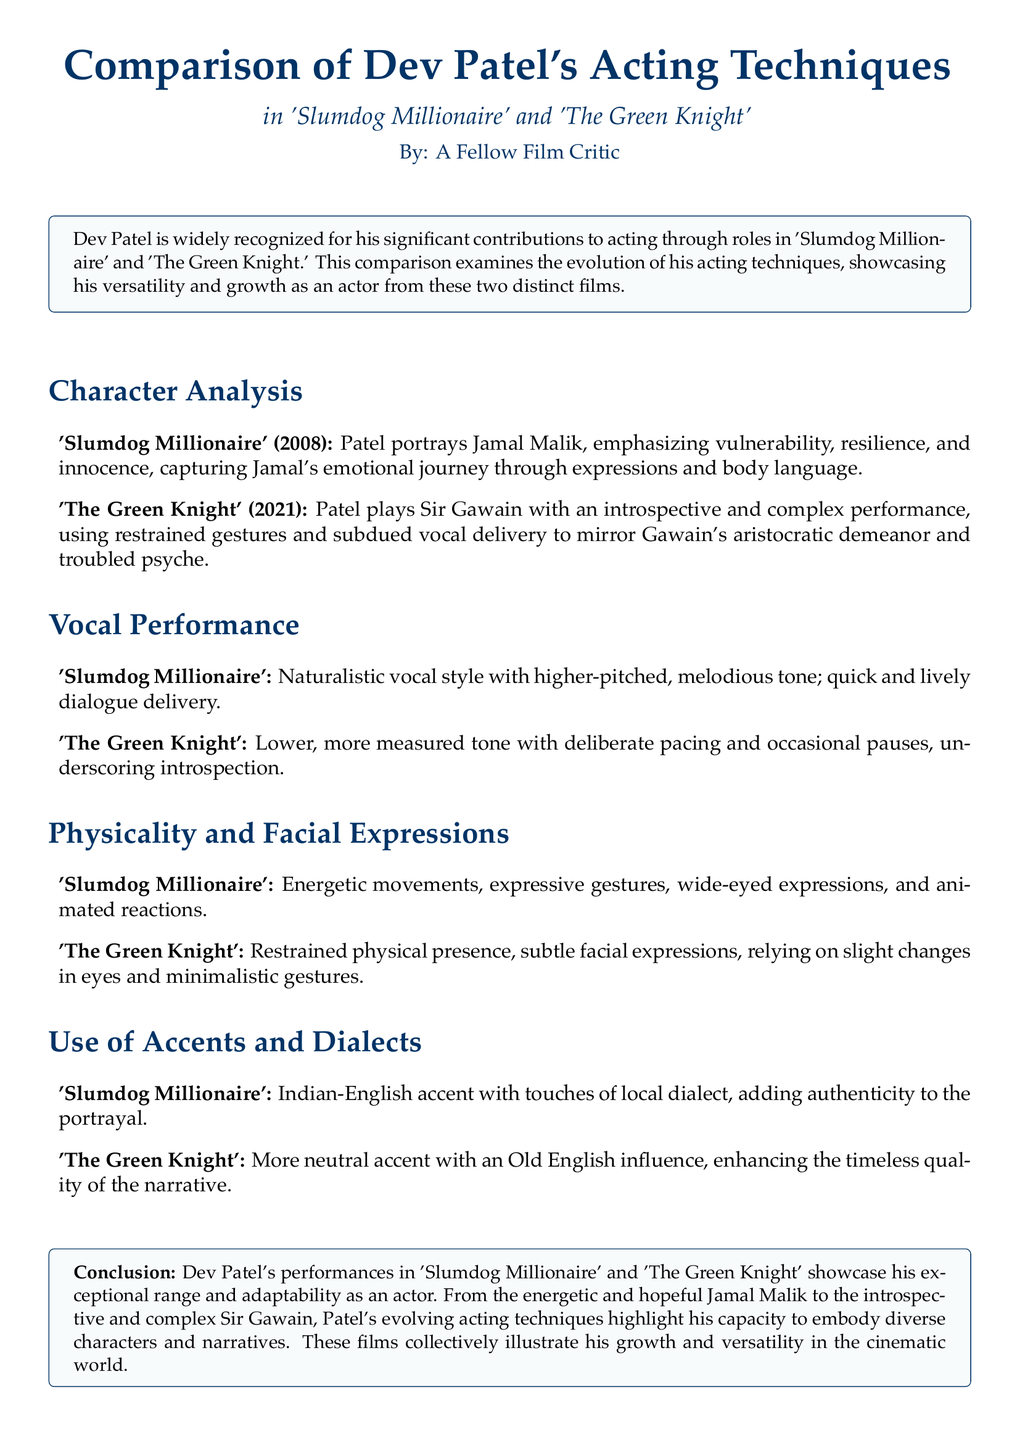What is the name of Dev Patel's character in 'Slumdog Millionaire'? The document states that Patel portrays Jamal Malik in 'Slumdog Millionaire'.
Answer: Jamal Malik What character does Dev Patel portray in 'The Green Knight'? The document indicates that Patel plays Sir Gawain in 'The Green Knight'.
Answer: Sir Gawain What year was 'Slumdog Millionaire' released? The document mentions that 'Slumdog Millionaire' was released in 2008.
Answer: 2008 What type of vocal style does Patel use in 'Slumdog Millionaire'? The document describes Patel's vocal style in 'Slumdog Millionaire' as naturalistic.
Answer: Naturalistic How does Dev Patel's physicality differ between the two films? According to the document, Patel exhibits energetic movements in 'Slumdog Millionaire' but has a restrained physical presence in 'The Green Knight'.
Answer: Energetic vs. restrained What accent does Patel use in 'Slumdog Millionaire'? The document states that he uses an Indian-English accent in 'Slumdog Millionaire'.
Answer: Indian-English What is the conclusion regarding Patel's acting in the document? The document concludes that Patel's performances showcase his exceptional range and adaptability as an actor.
Answer: Exceptional range and adaptability How does Patel's vocal delivery in 'The Green Knight' differ from 'Slumdog Millionaire'? The document explains that in 'The Green Knight', he uses a lower, more measured tone with deliberate pacing, compared to the quick delivery in 'Slumdog Millionaire'.
Answer: Lower, measured tone What does the character Jamal Malik embody in 'Slumdog Millionaire'? The document states that Jamal Malik embodies vulnerability, resilience, and innocence.
Answer: Vulnerability, resilience, and innocence 